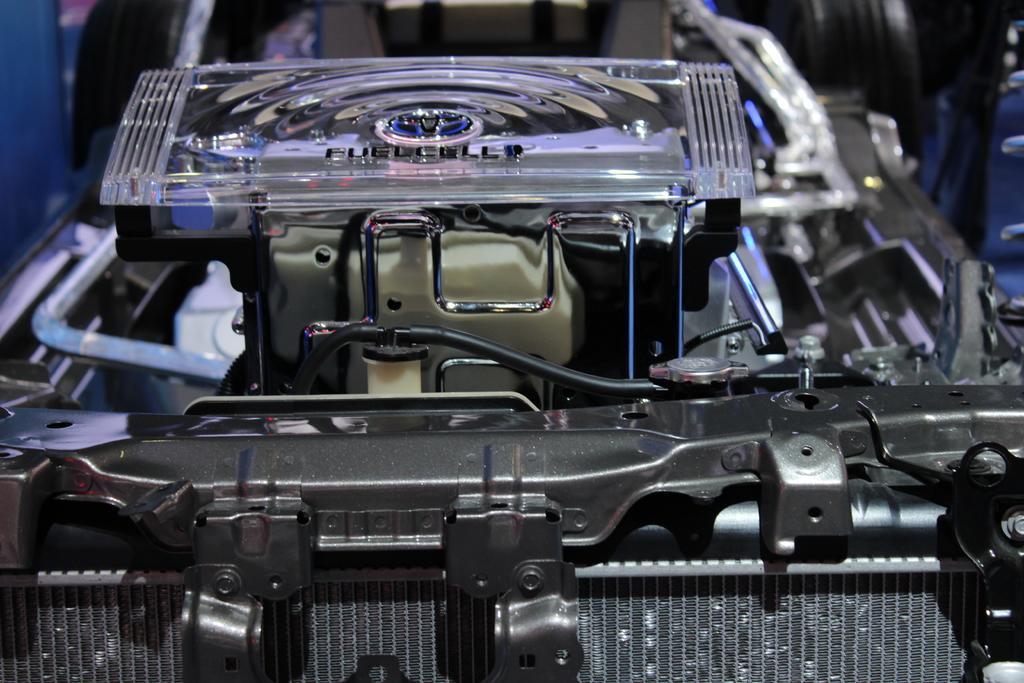Can you describe this image briefly? In the picture we can see a part of the vehicle engine with wires and top of it we can see a glass fuel cell. 